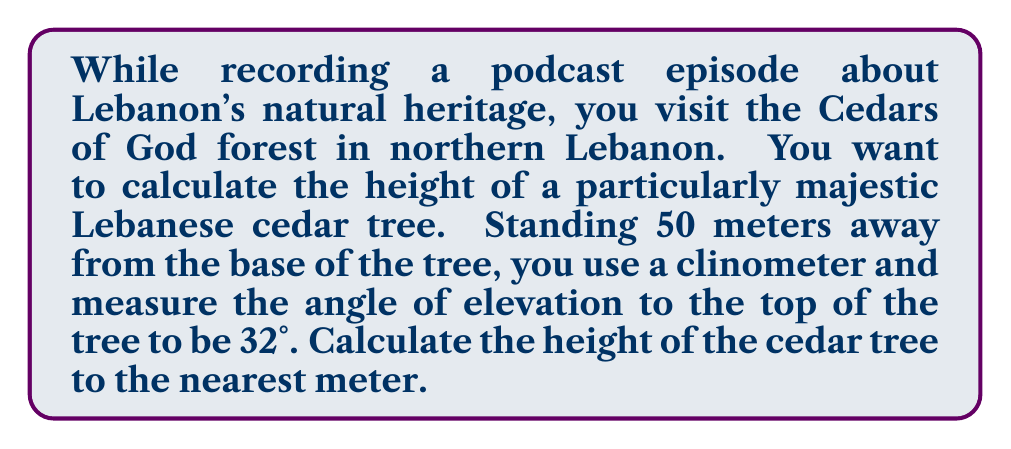Can you solve this math problem? Let's approach this problem step-by-step using trigonometry:

1) First, let's visualize the problem:

[asy]
import geometry;

size(200);
pair A = (0,0), B = (5,0), C = (5,3);
draw(A--B--C--A);
label("50 m", (2.5,0), S);
label("h", (5,1.5), E);
label("32°", (0.5,0.3), NW);
draw(A--(0,0.5)--(.5,0.5)--A);
[/asy]

2) We can see that this forms a right-angled triangle, where:
   - The base of the triangle is the distance from you to the tree (50 m)
   - The height of the triangle is the height of the tree (h)
   - The angle of elevation is 32°

3) In this right-angled triangle, we can use the tangent ratio:

   $$ \tan(\theta) = \frac{\text{opposite}}{\text{adjacent}} $$

4) In our case:
   $$ \tan(32°) = \frac{h}{50} $$

5) To find h, we can rearrange this equation:
   $$ h = 50 \times \tan(32°) $$

6) Now we can calculate:
   $$ h = 50 \times \tan(32°) $$
   $$ h = 50 \times 0.6249 $$
   $$ h = 31.245 \text{ meters} $$

7) Rounding to the nearest meter:
   $$ h \approx 31 \text{ meters} $$
Answer: The height of the Lebanese cedar tree is approximately 31 meters. 